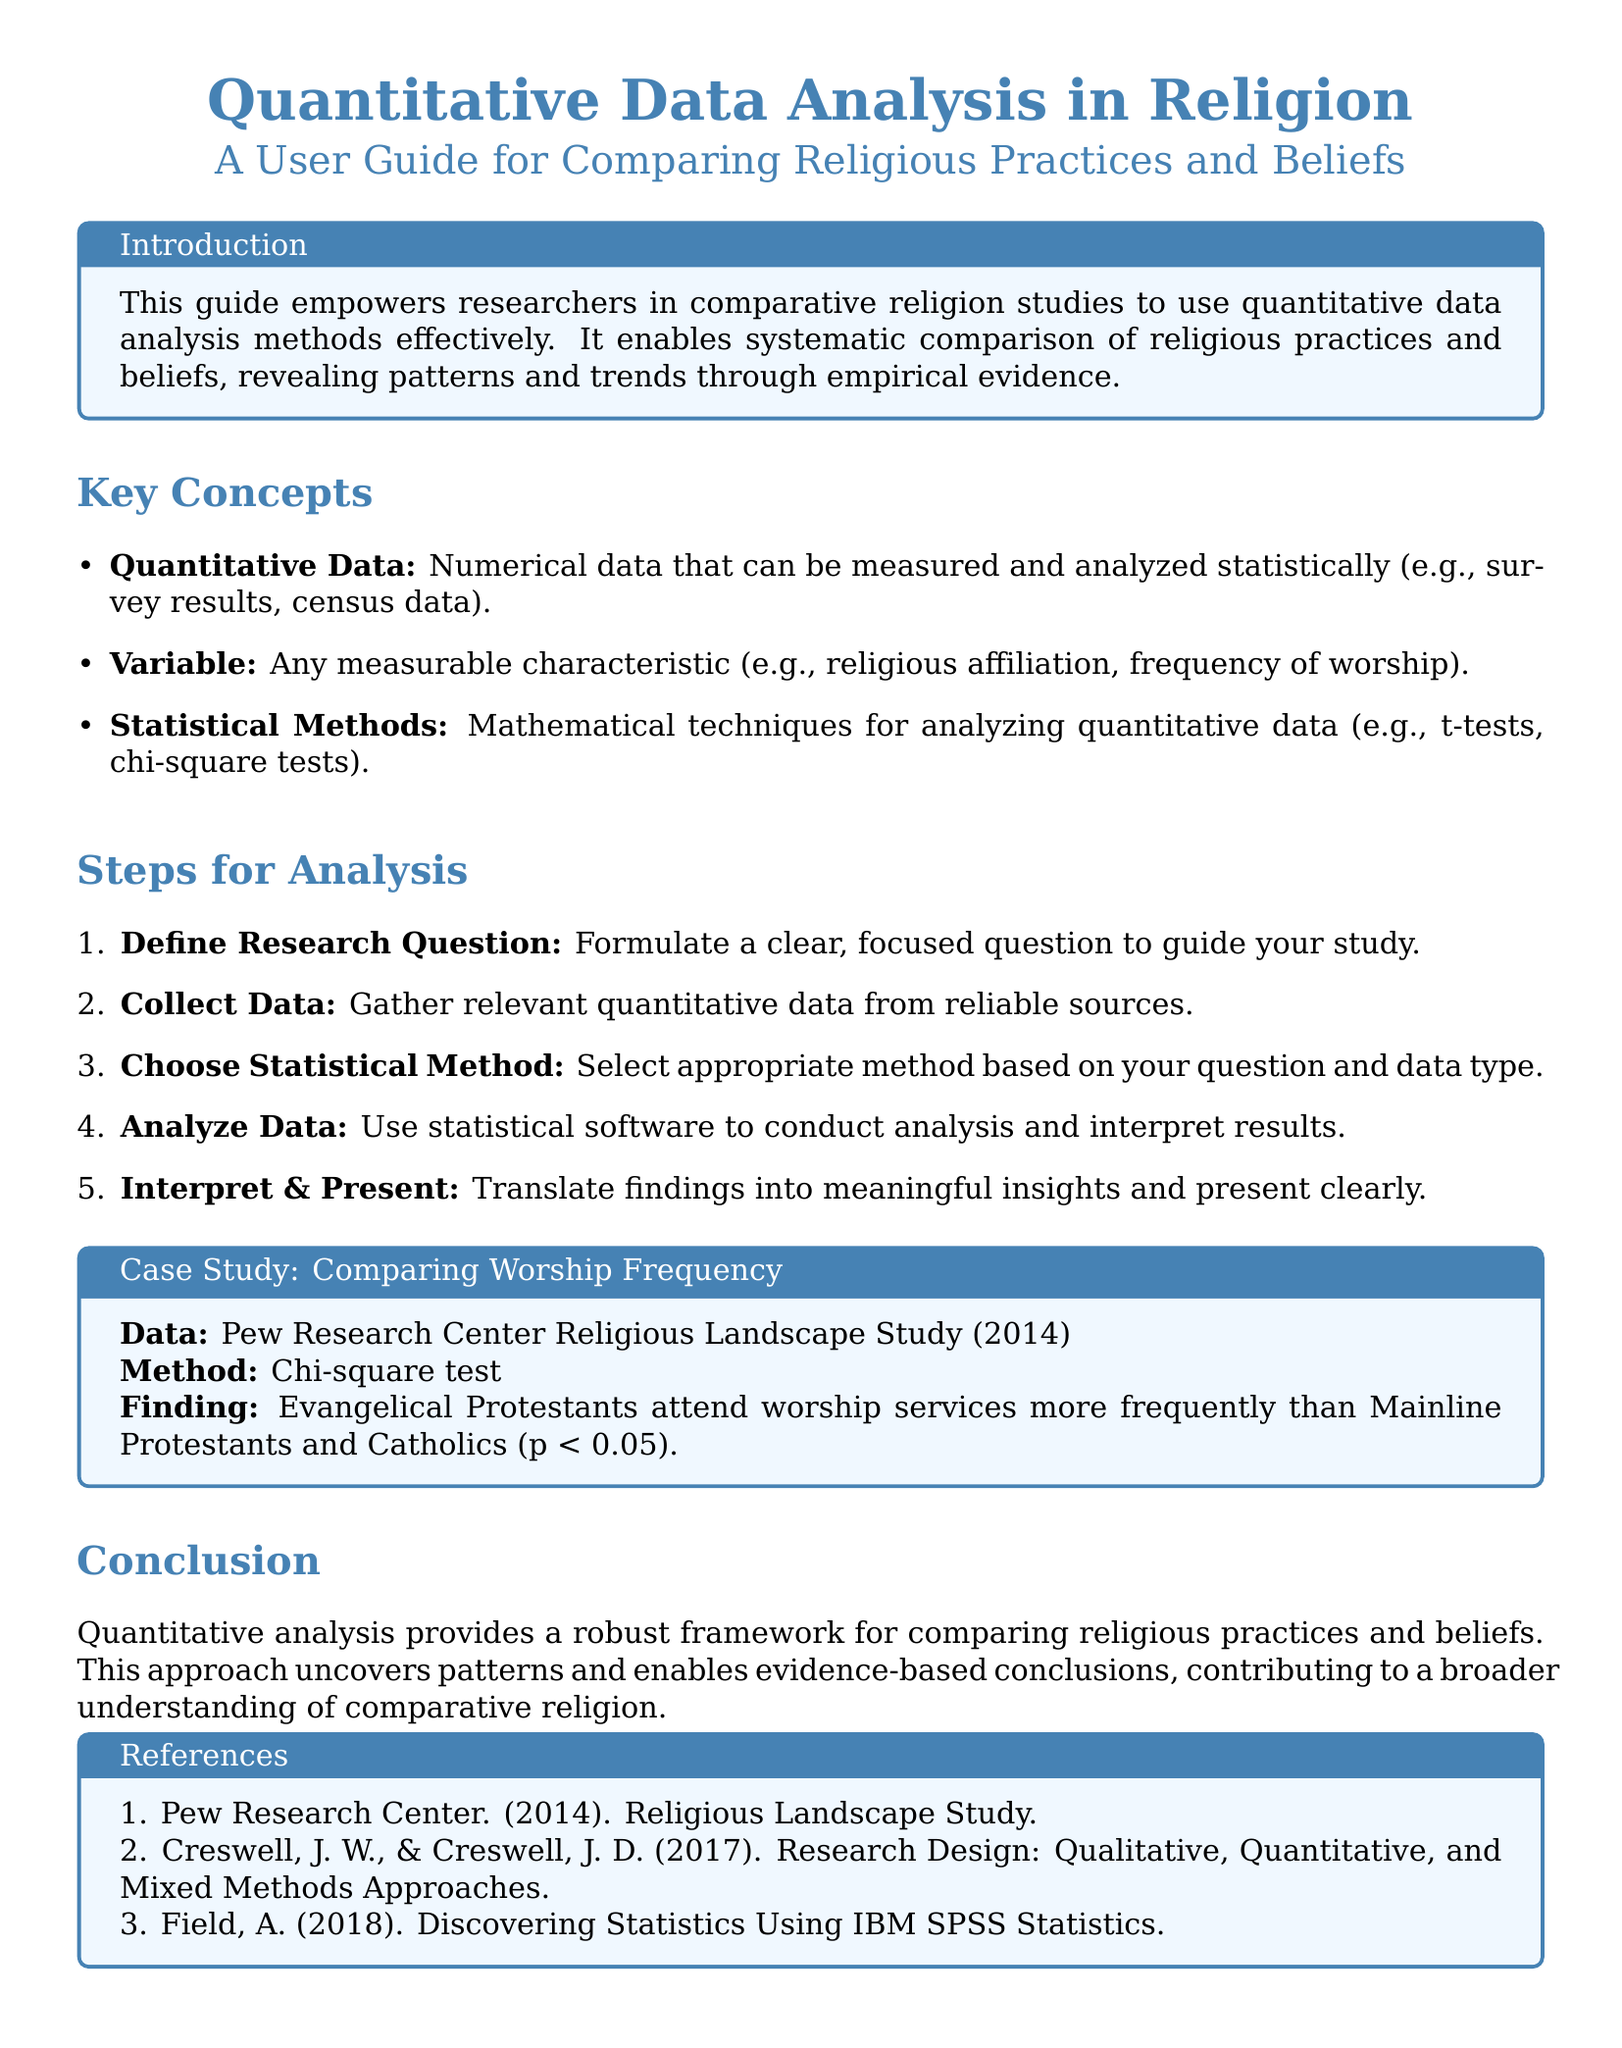what is the main purpose of the guide? The guide is designed to empower researchers in comparative religion studies to effectively use quantitative data analysis methods.
Answer: empower researchers what statistical method is mentioned in the case study? The case study mentions the chi-square test as the statistical method used for analysis.
Answer: chi-square test how many steps are outlined for analysis? There are five steps outlined in the "Steps for Analysis" section of the document.
Answer: five what finding was reported in the case study? The finding reported is that Evangelical Protestants attend worship services more frequently than Mainline Protestants and Catholics.
Answer: Evangelical Protestants attend worship services more frequently which source provided the data for the case study? The data for the case study was sourced from the Pew Research Center Religious Landscape Study (2014).
Answer: Pew Research Center Religious Landscape Study what is the first step in the analysis process? The first step in the analysis process is to define the research question.
Answer: define research question 